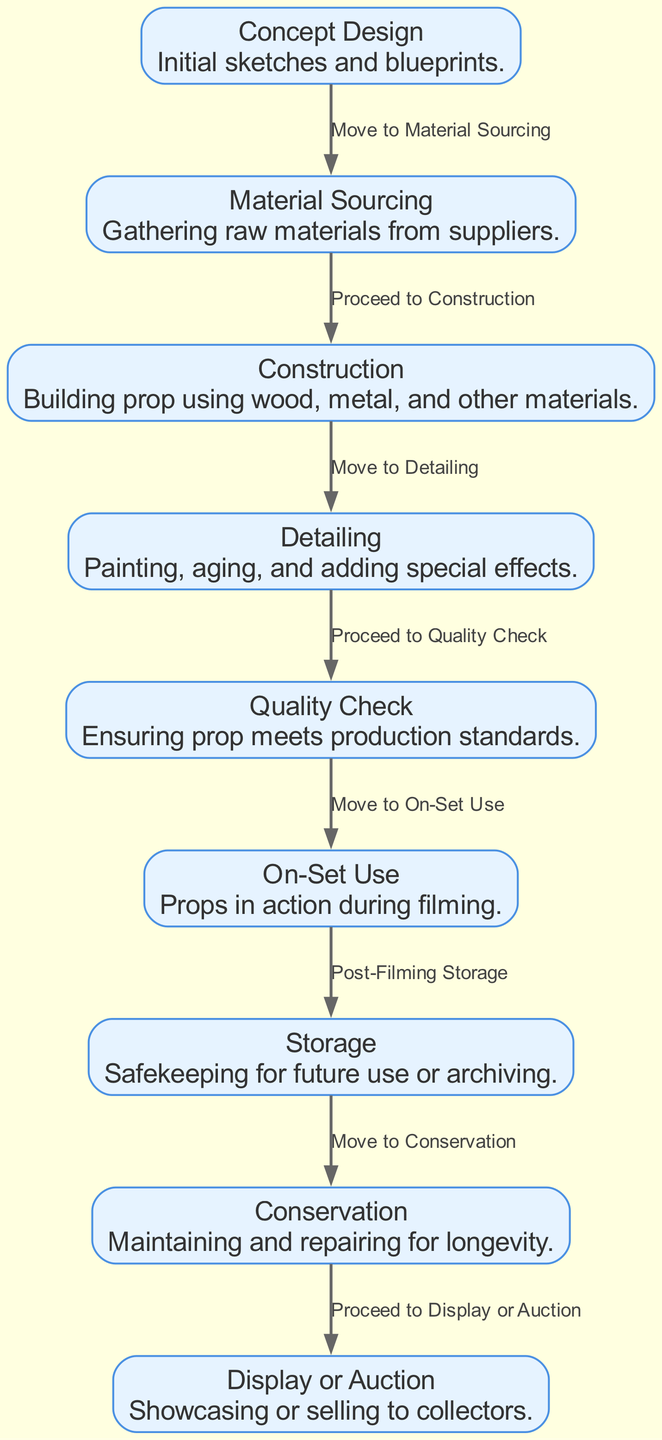What is the first step in the life cycle of movie props? The first step, as indicated by the first node in the diagram, is "Concept Design", where initial sketches and blueprints are created.
Answer: Concept Design How many nodes are in the diagram? The diagram displays a total of nine nodes representing different stages in the life cycle of movie props.
Answer: 9 What comes after detailing? Detailing leads to the next step identified as "Quality Check", which ensures the prop meets the production standards.
Answer: Quality Check What is the final step in the life cycle? The final step is "Display or Auction", which involves showcasing or selling the props to collectors.
Answer: Display or Auction What is the relationship between "On-Set Use" and "Storage"? The relationship described shows that after "On-Set Use", the props move to "Storage" for safekeeping, as indicated by the edge connecting these two nodes.
Answer: Post-Filming Storage Which step involves maintenance for longevity? The step focusing on maintenance and repair for longevity is "Conservation", indicating care to preserve the props over time.
Answer: Conservation How many edges are present in the diagram? There are a total of eight edges connecting the various nodes, illustrating the flow of the life cycle.
Answer: 8 Which two nodes are directly connected by an edge labeled "Proceed to Construction"? The nodes "Material Sourcing" and "Construction" are directly connected by the edge labeled "Proceed to Construction", indicating the progression from sourcing materials to building the prop.
Answer: Material Sourcing, Construction Which stage comes immediately before "On-Set Use"? The stage that comes directly before "On-Set Use" is "Quality Check", ensuring the props are ready for action during filming.
Answer: Quality Check 